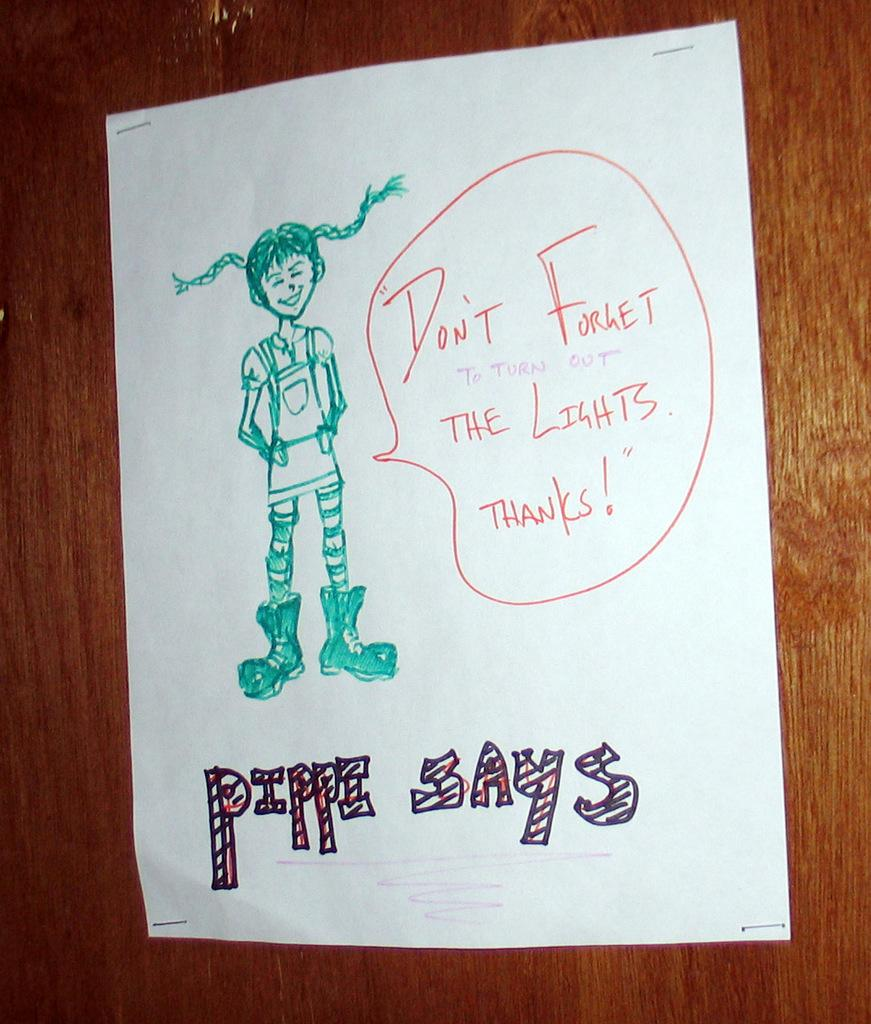What is the main object in the image? There is a paper in the image. What can be found on the paper? The paper contains pictures and text. What type of surface is visible in the background of the image? There is a wooden surface in the background of the image. How many pans are stacked on the wooden surface in the image? There are no pans present in the image; it only features a paper with pictures and text. What number is written on the paper in the image? The provided facts do not mention any specific numbers on the paper, so we cannot determine that information from the image. 